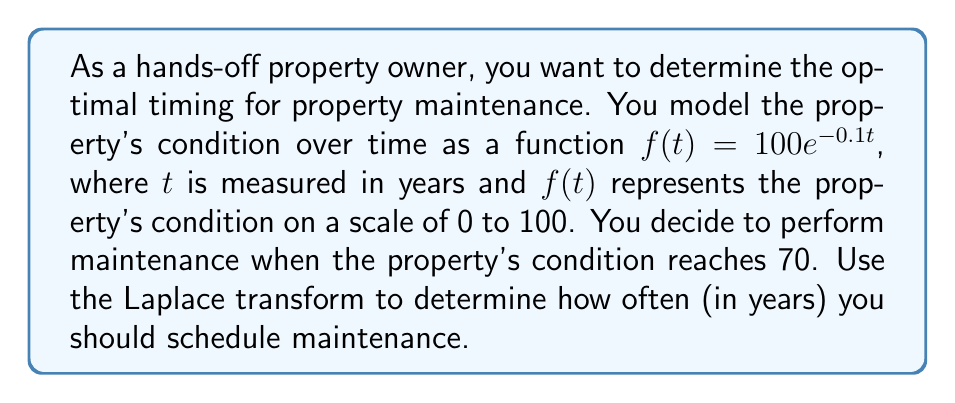Show me your answer to this math problem. To solve this problem, we'll follow these steps:

1) First, we need to find the time $t$ when $f(t) = 70$. This gives us the equation:
   
   $$70 = 100e^{-0.1t}$$

2) Solving for $t$:
   
   $$\begin{align}
   0.7 &= e^{-0.1t} \\
   \ln(0.7) &= -0.1t \\
   t &= -\frac{\ln(0.7)}{0.1} \approx 3.57 \text{ years}
   \end{align}$$

3) Now, we can use the Laplace transform to represent this periodic maintenance schedule. Let $g(t)$ be a function that jumps from 0 to 1 every 3.57 years:

   $$g(t) = \sum_{n=0}^{\infty} u(t - 3.57n)$$

   where $u(t)$ is the unit step function.

4) The Laplace transform of $g(t)$ is:

   $$\begin{align}
   G(s) &= \mathcal{L}\{g(t)\} \\
   &= \sum_{n=0}^{\infty} e^{-3.57ns} \cdot \frac{1}{s} \\
   &= \frac{1}{s} \cdot \frac{1}{1 - e^{-3.57s}}
   \end{align}$$

5) This transform represents the periodic maintenance schedule in the s-domain. The poles of this function (where the denominator is zero) occur at:

   $$s = \frac{2\pi i k}{3.57}, \quad k = 0, \pm 1, \pm 2, ...$$

6) The fundamental frequency of this periodic function is given by the smallest non-zero value of $|s|$, which occurs when $k = \pm 1$:

   $$\omega = \frac{2\pi}{3.57} \approx 1.76 \text{ rad/year}$$

7) The period $T$ is the reciprocal of the frequency:

   $$T = \frac{2\pi}{\omega} = 3.57 \text{ years}$$

This confirms our initial calculation and provides a robust method for analyzing periodic maintenance schedules using Laplace transforms.
Answer: The optimal timing for property maintenance is approximately 3.57 years. 